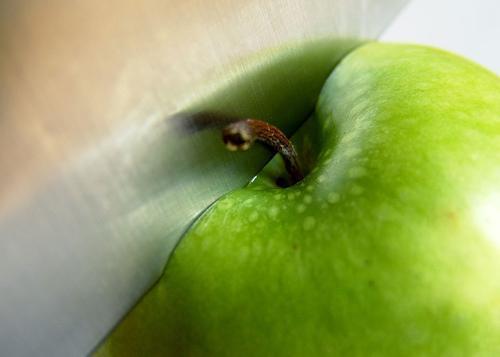How many knives can you see?
Give a very brief answer. 1. How many people are in the photo?
Give a very brief answer. 0. 